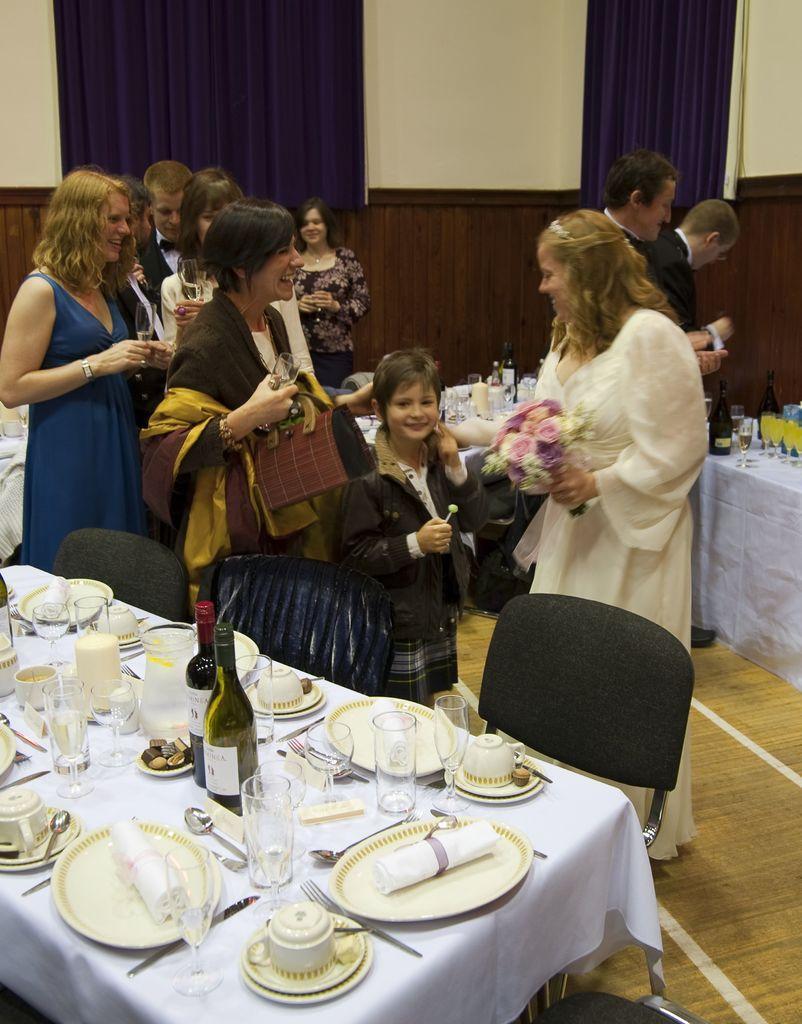Can you describe this image briefly? I can see in this image a group of people standing on the floor in front of a table. I can see there are chairs. On the table we have two glass bottles, plates and other objects on it in the background there are few curtains and white color wall 